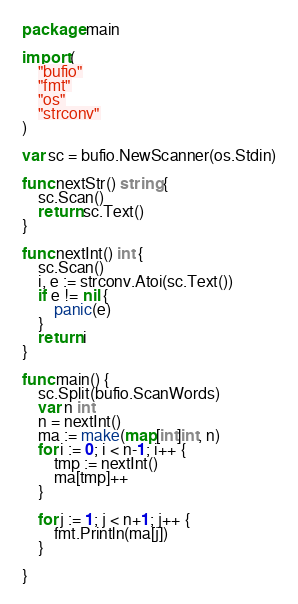<code> <loc_0><loc_0><loc_500><loc_500><_Go_>package main

import (
	"bufio"
	"fmt"
	"os"
	"strconv"
)

var sc = bufio.NewScanner(os.Stdin)

func nextStr() string {
	sc.Scan()
	return sc.Text()
}

func nextInt() int {
	sc.Scan()
	i, e := strconv.Atoi(sc.Text())
	if e != nil {
		panic(e)
	}
	return i
}

func main() {
	sc.Split(bufio.ScanWords)
	var n int
	n = nextInt()
	ma := make(map[int]int, n)
	for i := 0; i < n-1; i++ {
		tmp := nextInt()
		ma[tmp]++
	}

	for j := 1; j < n+1; j++ {
		fmt.Println(ma[j])
	}

}
</code> 